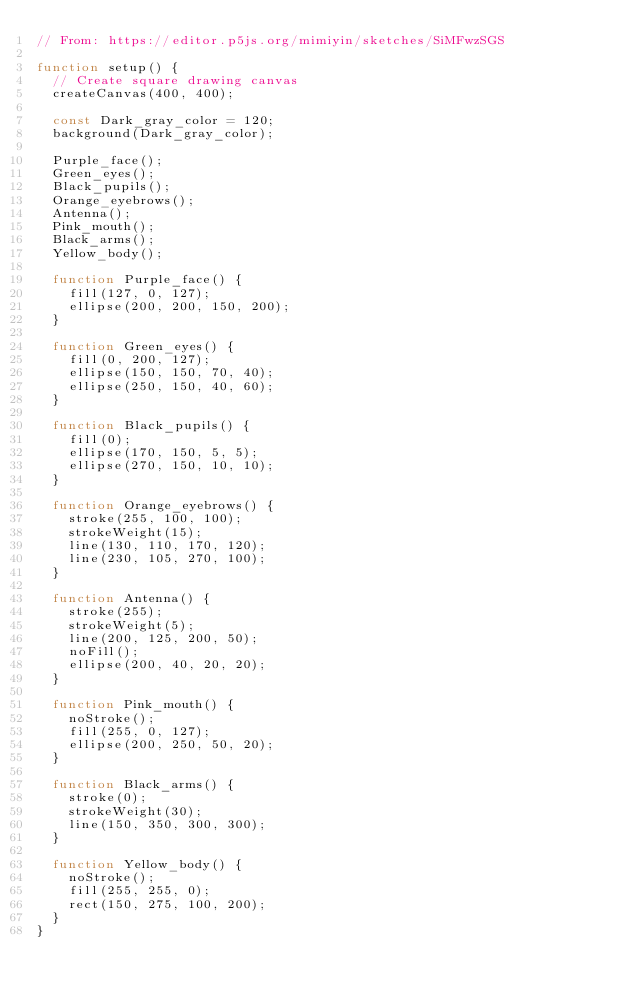<code> <loc_0><loc_0><loc_500><loc_500><_JavaScript_>// From: https://editor.p5js.org/mimiyin/sketches/SiMFwzSGS

function setup() {
  // Create square drawing canvas 
  createCanvas(400, 400);

  const Dark_gray_color = 120;
  background(Dark_gray_color);

  Purple_face();
  Green_eyes();
  Black_pupils();
  Orange_eyebrows();
  Antenna();
  Pink_mouth();
  Black_arms();
  Yellow_body();

  function Purple_face() {
    fill(127, 0, 127);
    ellipse(200, 200, 150, 200);
  }

  function Green_eyes() {
    fill(0, 200, 127);
    ellipse(150, 150, 70, 40);
    ellipse(250, 150, 40, 60);
  }

  function Black_pupils() {
    fill(0);
    ellipse(170, 150, 5, 5);
    ellipse(270, 150, 10, 10);
  }

  function Orange_eyebrows() {
    stroke(255, 100, 100);
    strokeWeight(15);
    line(130, 110, 170, 120);
    line(230, 105, 270, 100);
  }

  function Antenna() {
    stroke(255);
    strokeWeight(5);
    line(200, 125, 200, 50);
    noFill();
    ellipse(200, 40, 20, 20);
  }

  function Pink_mouth() {
    noStroke();
    fill(255, 0, 127);
    ellipse(200, 250, 50, 20);
  }

  function Black_arms() {
    stroke(0);
    strokeWeight(30);
    line(150, 350, 300, 300);
  }

  function Yellow_body() {
    noStroke();
    fill(255, 255, 0);
    rect(150, 275, 100, 200);
  }
}</code> 